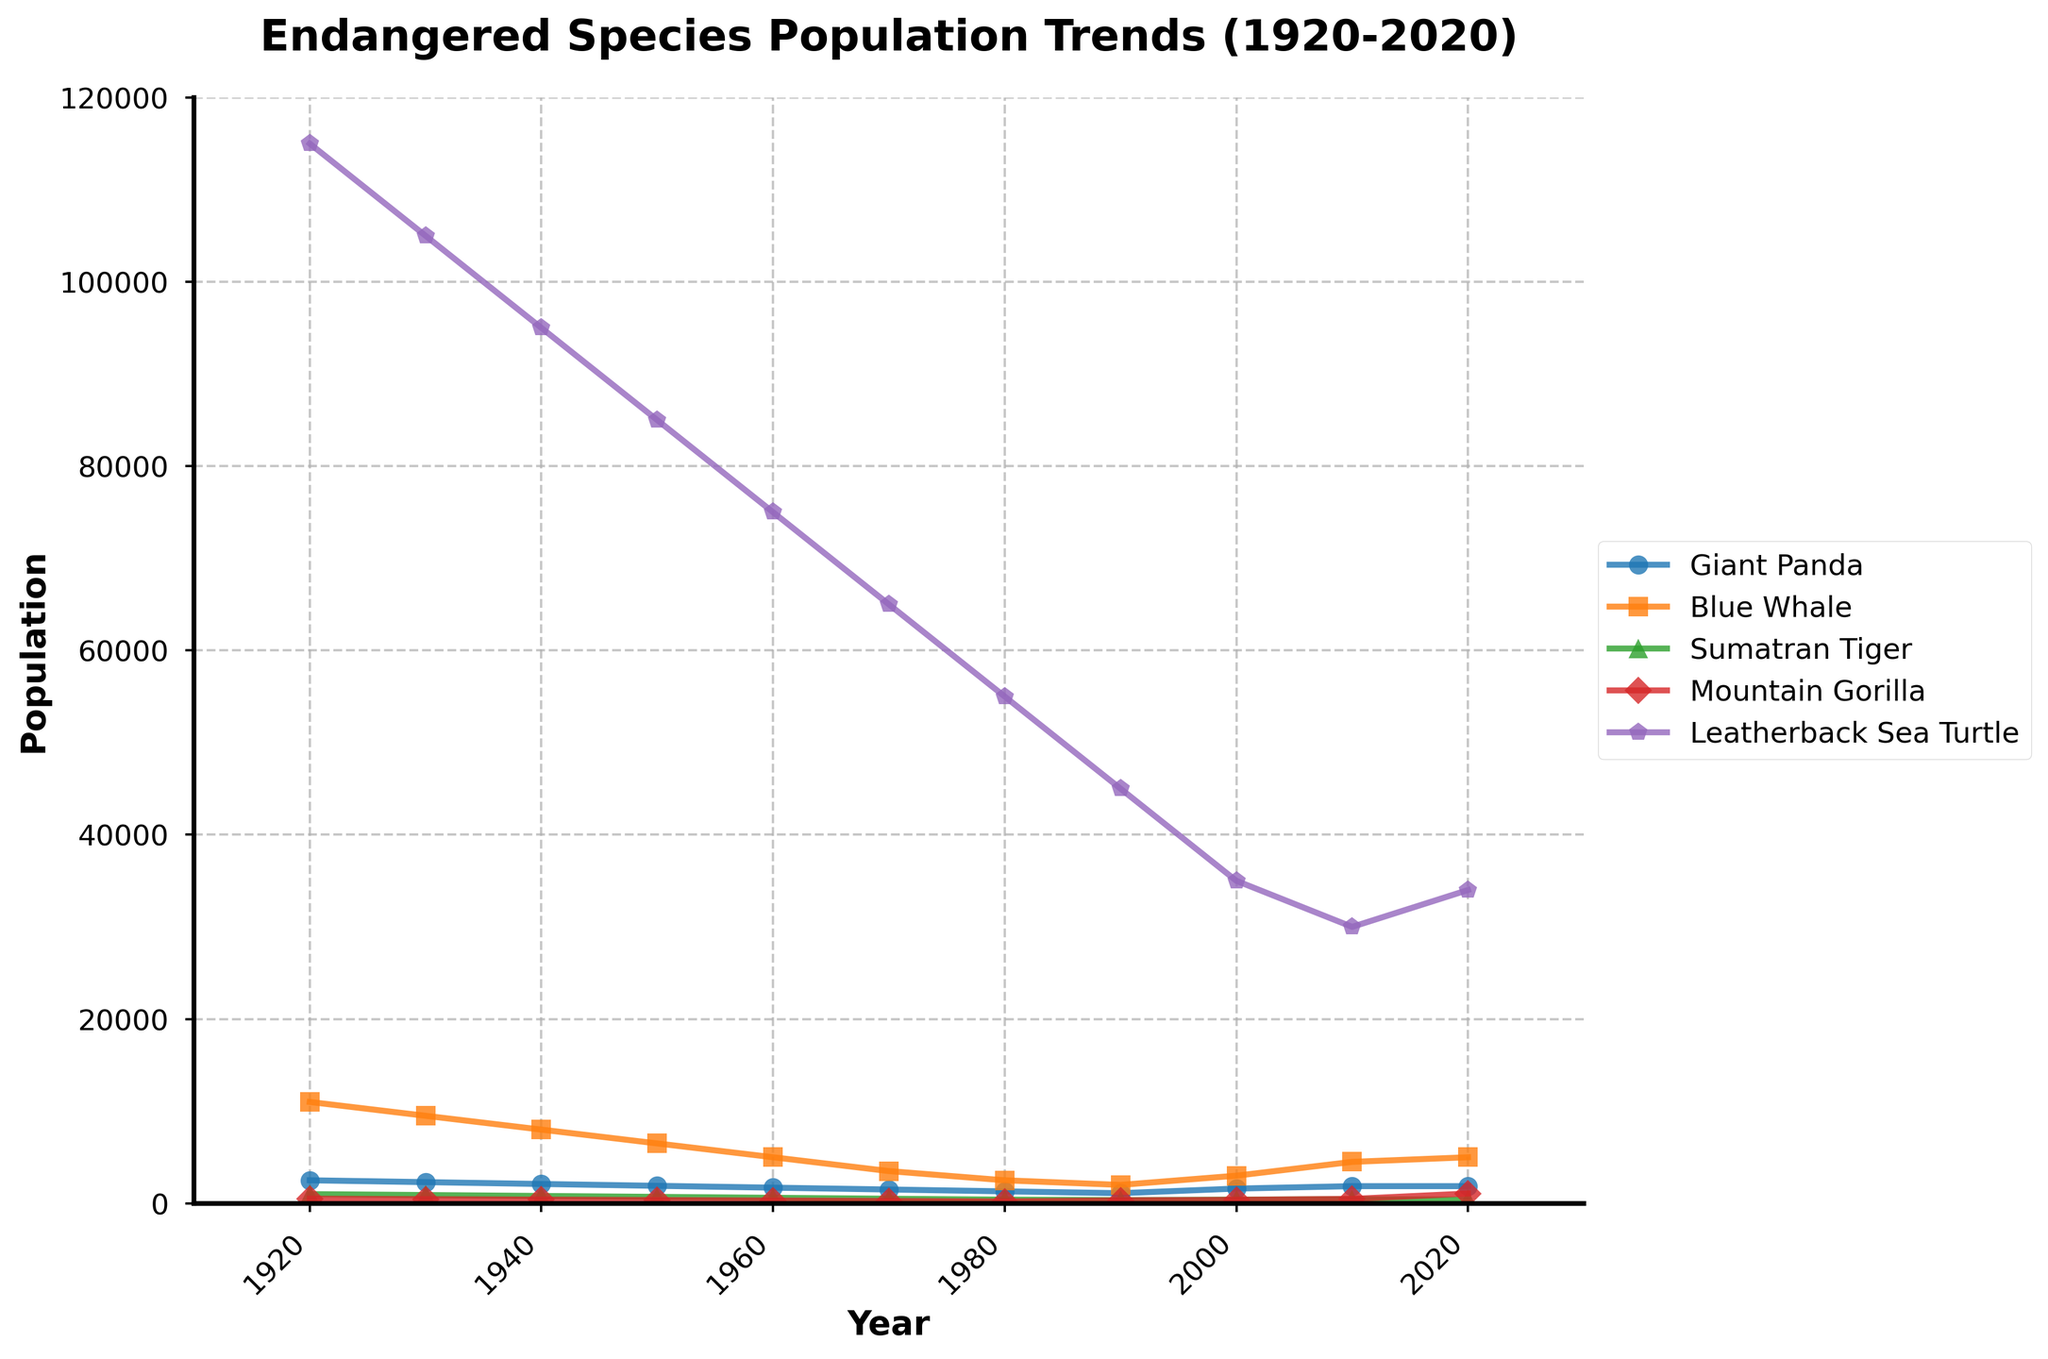What is the trend in the population of the Mountain Gorilla between 1960 and 2020? The Mountain Gorilla population exhibits a downward trend from 1960 to 1990, decreasing from 300 to 320. Thereafter, it recovers and shows a significant increase to 1063 in 2020.
Answer: Downward trend until 1990, then significant increase Which species has the highest population in the year 1920? From the figure, in 1920, the Leatherback Sea Turtle population (~115,000) is the highest compared to the other species.
Answer: Leatherback Sea Turtle Between the Blue Whale and the Giant Panda, which species showed a more significant decline between 1920 and 1980? The Blue Whale population declined from around 11,000 to 2,500, a reduction of ~8,500. The Giant Panda declined from 2,500 to 1,300, a reduction of 1,200. Thus, the Blue Whale showed a more significant decline.
Answer: Blue Whale What is the difference in the population of the Sumatran Tiger between 1970 and 2020? In 1970, the Sumatran Tiger population was 500. In 2020, it dropped to 400. The difference is 500 - 400 = 100.
Answer: 100 What species showed an increase in their population between 2000 and 2020? Examining the figure, the populations of the Blue Whale (3,000 to 5,000), Mountain Gorilla (380 to 1063), and Leatherback Sea Turtle (35,000 to 34,000) increased from 2000 to 2020.
Answer: Blue Whale and Mountain Gorilla Which species had the most notable population recovery in the last decade (2010-2020)? The Mountain Gorilla saw a remarkable increase in population from 480 in 2010 to 1063 in 2020.
Answer: Mountain Gorilla During what years did the Giant Panda population show an increase? According to the figure, the Giant Panda population increased between 1990 (1100) to 2000 (1600) and 2000 (1600) to 2010 (1864).
Answer: 1990-2000 and 2000-2010 Which species had the smallest population in 1980? The Sumatran Tiger had the smallest population in 1980 with just 400 individuals.
Answer: Sumatran Tiger Comparing the populations of Giant Panda and Leatherback Sea Turtle in 1940, which had a higher count? In 1940, the Leatherback Sea Turtle population (~95,000) was much higher than the Giant Panda population (~2,100).
Answer: Leatherback Sea Turtle What is the average population of the Blue Whale between 1920 and 2020? The Blue Whale populations from 1920 to 2020 are: 11000, 9500, 8000, 6500, 5000, 3500, 2500, 2000, 3000, 4500, 5000. Adding these: 11000 + 9500 + 8000 + 6500 + 5000 + 3500 + 2500 + 2000 + 3000 + 4500 + 5000 = 58500. Dividing by 11 years, the average population is 58500/11 ≈ 5318.
Answer: 5318 